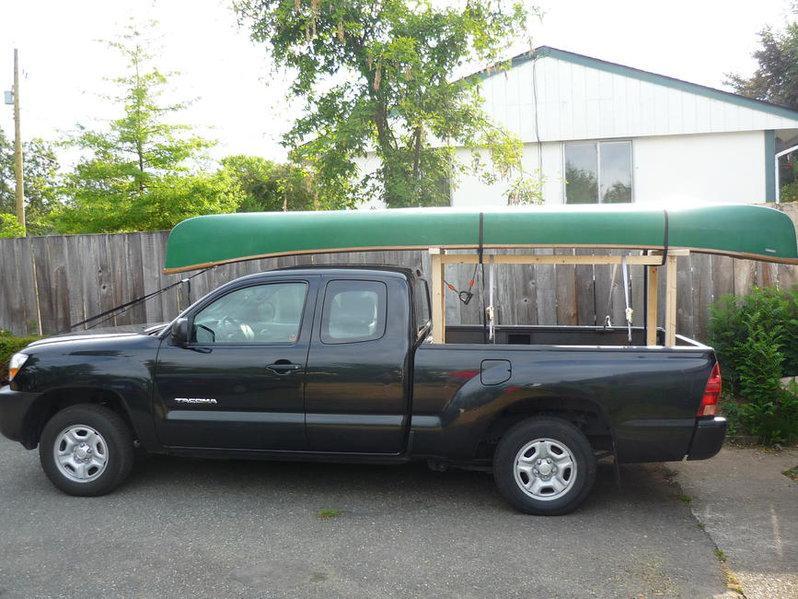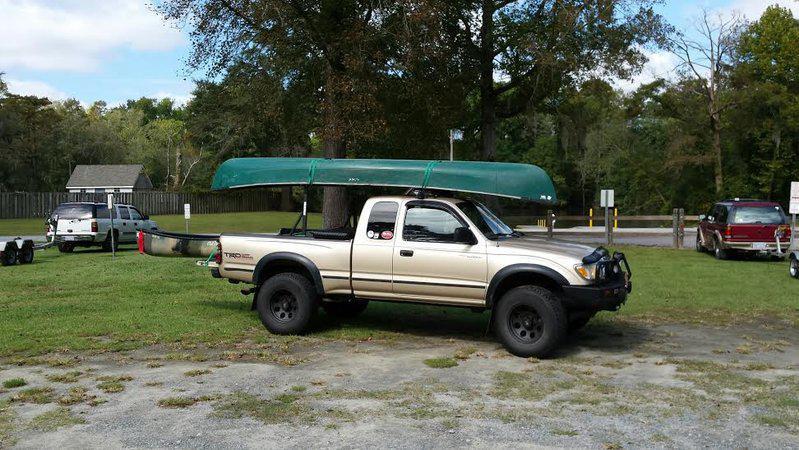The first image is the image on the left, the second image is the image on the right. For the images displayed, is the sentence "One of the images contains at least one red kayak." factually correct? Answer yes or no. No. 